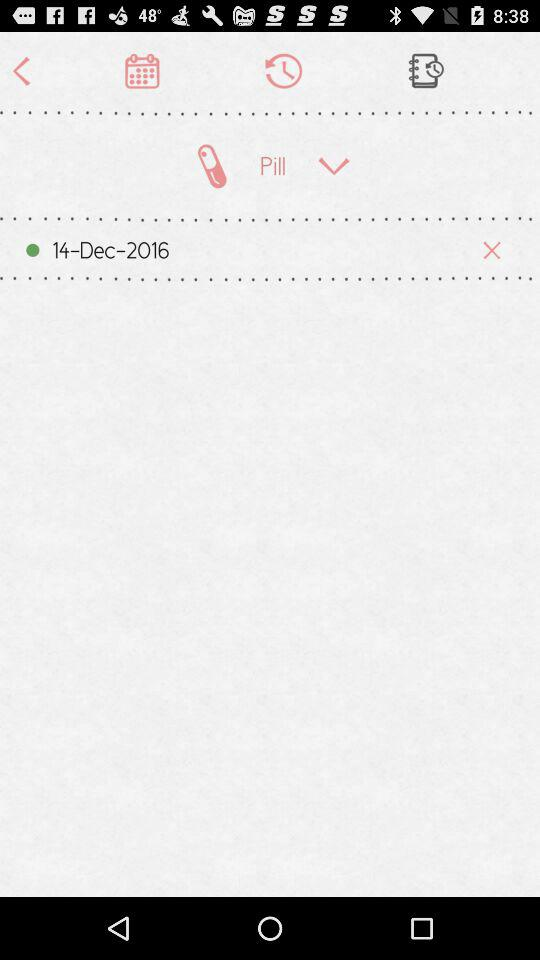How can we sign in?
When the provided information is insufficient, respond with <no answer>. <no answer> 